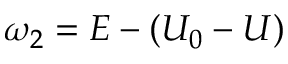<formula> <loc_0><loc_0><loc_500><loc_500>\omega _ { 2 } = E - ( U _ { 0 } - U )</formula> 